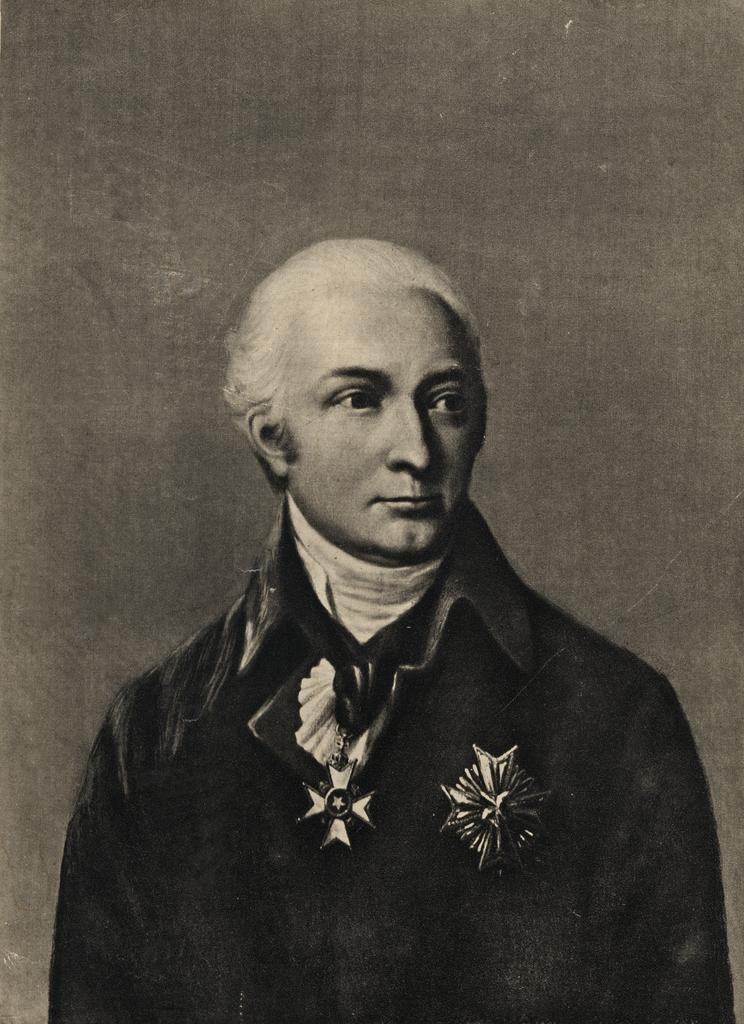What is the color scheme of the image? The image is black and white. Can you describe the main subject of the image? There is a person in the image. Where is the zoo located in the image? There is no zoo present in the image. What type of jar is visible on the person's head in the image? There is no jar visible on the person's head in the image. 